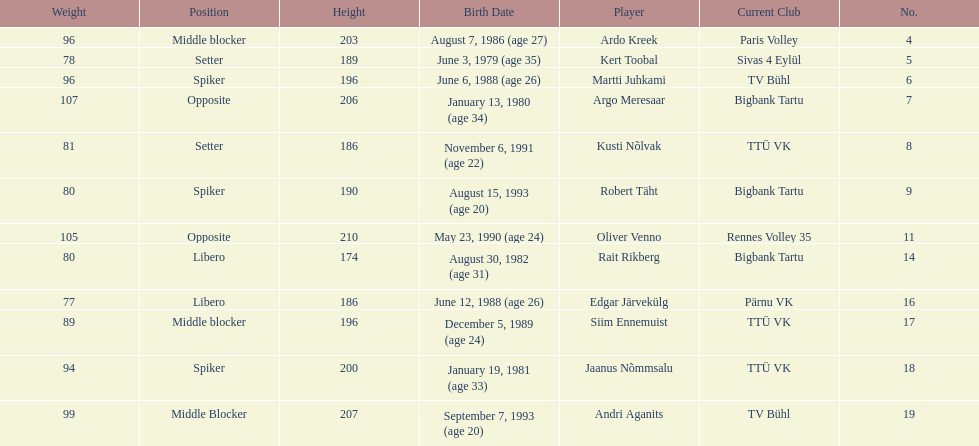How many players are middle blockers? 3. 